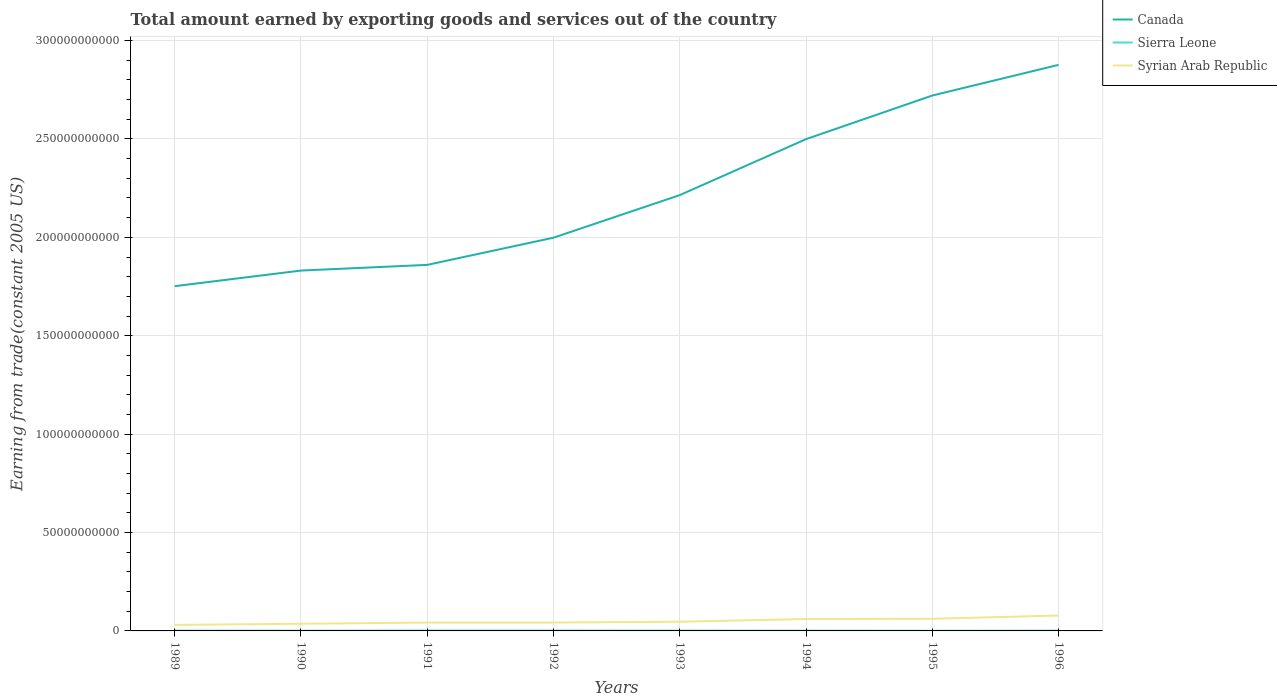How many different coloured lines are there?
Your answer should be very brief. 3. Is the number of lines equal to the number of legend labels?
Ensure brevity in your answer.  Yes. Across all years, what is the maximum total amount earned by exporting goods and services in Sierra Leone?
Offer a very short reply. 7.47e+07. What is the total total amount earned by exporting goods and services in Canada in the graph?
Your answer should be very brief. -2.16e+1. What is the difference between the highest and the second highest total amount earned by exporting goods and services in Canada?
Offer a very short reply. 1.12e+11. What is the difference between the highest and the lowest total amount earned by exporting goods and services in Syrian Arab Republic?
Offer a very short reply. 3. Is the total amount earned by exporting goods and services in Sierra Leone strictly greater than the total amount earned by exporting goods and services in Syrian Arab Republic over the years?
Make the answer very short. Yes. How many lines are there?
Ensure brevity in your answer.  3. Does the graph contain any zero values?
Make the answer very short. No. Does the graph contain grids?
Keep it short and to the point. Yes. Where does the legend appear in the graph?
Give a very brief answer. Top right. How many legend labels are there?
Offer a terse response. 3. How are the legend labels stacked?
Your answer should be compact. Vertical. What is the title of the graph?
Your response must be concise. Total amount earned by exporting goods and services out of the country. What is the label or title of the X-axis?
Your response must be concise. Years. What is the label or title of the Y-axis?
Provide a short and direct response. Earning from trade(constant 2005 US). What is the Earning from trade(constant 2005 US) in Canada in 1989?
Keep it short and to the point. 1.75e+11. What is the Earning from trade(constant 2005 US) of Sierra Leone in 1989?
Your answer should be very brief. 1.54e+08. What is the Earning from trade(constant 2005 US) of Syrian Arab Republic in 1989?
Provide a short and direct response. 3.07e+09. What is the Earning from trade(constant 2005 US) of Canada in 1990?
Make the answer very short. 1.83e+11. What is the Earning from trade(constant 2005 US) in Sierra Leone in 1990?
Your response must be concise. 1.25e+08. What is the Earning from trade(constant 2005 US) in Syrian Arab Republic in 1990?
Your response must be concise. 3.64e+09. What is the Earning from trade(constant 2005 US) of Canada in 1991?
Provide a succinct answer. 1.86e+11. What is the Earning from trade(constant 2005 US) in Sierra Leone in 1991?
Make the answer very short. 1.88e+08. What is the Earning from trade(constant 2005 US) of Syrian Arab Republic in 1991?
Your answer should be very brief. 4.25e+09. What is the Earning from trade(constant 2005 US) in Canada in 1992?
Your answer should be compact. 2.00e+11. What is the Earning from trade(constant 2005 US) in Sierra Leone in 1992?
Ensure brevity in your answer.  1.77e+08. What is the Earning from trade(constant 2005 US) of Syrian Arab Republic in 1992?
Make the answer very short. 4.25e+09. What is the Earning from trade(constant 2005 US) of Canada in 1993?
Keep it short and to the point. 2.21e+11. What is the Earning from trade(constant 2005 US) of Sierra Leone in 1993?
Keep it short and to the point. 1.53e+08. What is the Earning from trade(constant 2005 US) in Syrian Arab Republic in 1993?
Keep it short and to the point. 4.68e+09. What is the Earning from trade(constant 2005 US) in Canada in 1994?
Your answer should be very brief. 2.50e+11. What is the Earning from trade(constant 2005 US) in Sierra Leone in 1994?
Offer a very short reply. 1.17e+08. What is the Earning from trade(constant 2005 US) of Syrian Arab Republic in 1994?
Your answer should be very brief. 6.04e+09. What is the Earning from trade(constant 2005 US) of Canada in 1995?
Your response must be concise. 2.72e+11. What is the Earning from trade(constant 2005 US) in Sierra Leone in 1995?
Offer a very short reply. 7.47e+07. What is the Earning from trade(constant 2005 US) in Syrian Arab Republic in 1995?
Make the answer very short. 6.16e+09. What is the Earning from trade(constant 2005 US) of Canada in 1996?
Make the answer very short. 2.88e+11. What is the Earning from trade(constant 2005 US) in Sierra Leone in 1996?
Make the answer very short. 1.32e+08. What is the Earning from trade(constant 2005 US) of Syrian Arab Republic in 1996?
Make the answer very short. 7.84e+09. Across all years, what is the maximum Earning from trade(constant 2005 US) of Canada?
Ensure brevity in your answer.  2.88e+11. Across all years, what is the maximum Earning from trade(constant 2005 US) of Sierra Leone?
Your response must be concise. 1.88e+08. Across all years, what is the maximum Earning from trade(constant 2005 US) of Syrian Arab Republic?
Keep it short and to the point. 7.84e+09. Across all years, what is the minimum Earning from trade(constant 2005 US) of Canada?
Your response must be concise. 1.75e+11. Across all years, what is the minimum Earning from trade(constant 2005 US) of Sierra Leone?
Your response must be concise. 7.47e+07. Across all years, what is the minimum Earning from trade(constant 2005 US) of Syrian Arab Republic?
Keep it short and to the point. 3.07e+09. What is the total Earning from trade(constant 2005 US) of Canada in the graph?
Make the answer very short. 1.78e+12. What is the total Earning from trade(constant 2005 US) in Sierra Leone in the graph?
Provide a short and direct response. 1.12e+09. What is the total Earning from trade(constant 2005 US) of Syrian Arab Republic in the graph?
Your answer should be very brief. 3.99e+1. What is the difference between the Earning from trade(constant 2005 US) of Canada in 1989 and that in 1990?
Offer a very short reply. -7.93e+09. What is the difference between the Earning from trade(constant 2005 US) in Sierra Leone in 1989 and that in 1990?
Your answer should be compact. 2.88e+07. What is the difference between the Earning from trade(constant 2005 US) in Syrian Arab Republic in 1989 and that in 1990?
Your answer should be compact. -5.73e+08. What is the difference between the Earning from trade(constant 2005 US) of Canada in 1989 and that in 1991?
Your answer should be compact. -1.08e+1. What is the difference between the Earning from trade(constant 2005 US) of Sierra Leone in 1989 and that in 1991?
Your response must be concise. -3.45e+07. What is the difference between the Earning from trade(constant 2005 US) of Syrian Arab Republic in 1989 and that in 1991?
Provide a succinct answer. -1.18e+09. What is the difference between the Earning from trade(constant 2005 US) of Canada in 1989 and that in 1992?
Give a very brief answer. -2.46e+1. What is the difference between the Earning from trade(constant 2005 US) of Sierra Leone in 1989 and that in 1992?
Give a very brief answer. -2.33e+07. What is the difference between the Earning from trade(constant 2005 US) of Syrian Arab Republic in 1989 and that in 1992?
Make the answer very short. -1.19e+09. What is the difference between the Earning from trade(constant 2005 US) in Canada in 1989 and that in 1993?
Provide a short and direct response. -4.63e+1. What is the difference between the Earning from trade(constant 2005 US) of Sierra Leone in 1989 and that in 1993?
Provide a succinct answer. 3.92e+05. What is the difference between the Earning from trade(constant 2005 US) of Syrian Arab Republic in 1989 and that in 1993?
Make the answer very short. -1.61e+09. What is the difference between the Earning from trade(constant 2005 US) in Canada in 1989 and that in 1994?
Give a very brief answer. -7.47e+1. What is the difference between the Earning from trade(constant 2005 US) in Sierra Leone in 1989 and that in 1994?
Your answer should be very brief. 3.69e+07. What is the difference between the Earning from trade(constant 2005 US) of Syrian Arab Republic in 1989 and that in 1994?
Provide a succinct answer. -2.98e+09. What is the difference between the Earning from trade(constant 2005 US) in Canada in 1989 and that in 1995?
Keep it short and to the point. -9.69e+1. What is the difference between the Earning from trade(constant 2005 US) of Sierra Leone in 1989 and that in 1995?
Provide a succinct answer. 7.91e+07. What is the difference between the Earning from trade(constant 2005 US) of Syrian Arab Republic in 1989 and that in 1995?
Give a very brief answer. -3.09e+09. What is the difference between the Earning from trade(constant 2005 US) in Canada in 1989 and that in 1996?
Make the answer very short. -1.12e+11. What is the difference between the Earning from trade(constant 2005 US) of Sierra Leone in 1989 and that in 1996?
Offer a very short reply. 2.21e+07. What is the difference between the Earning from trade(constant 2005 US) in Syrian Arab Republic in 1989 and that in 1996?
Your answer should be very brief. -4.77e+09. What is the difference between the Earning from trade(constant 2005 US) in Canada in 1990 and that in 1991?
Ensure brevity in your answer.  -2.90e+09. What is the difference between the Earning from trade(constant 2005 US) of Sierra Leone in 1990 and that in 1991?
Make the answer very short. -6.33e+07. What is the difference between the Earning from trade(constant 2005 US) in Syrian Arab Republic in 1990 and that in 1991?
Provide a short and direct response. -6.11e+08. What is the difference between the Earning from trade(constant 2005 US) in Canada in 1990 and that in 1992?
Provide a short and direct response. -1.67e+1. What is the difference between the Earning from trade(constant 2005 US) of Sierra Leone in 1990 and that in 1992?
Provide a short and direct response. -5.21e+07. What is the difference between the Earning from trade(constant 2005 US) in Syrian Arab Republic in 1990 and that in 1992?
Provide a succinct answer. -6.13e+08. What is the difference between the Earning from trade(constant 2005 US) in Canada in 1990 and that in 1993?
Offer a terse response. -3.83e+1. What is the difference between the Earning from trade(constant 2005 US) in Sierra Leone in 1990 and that in 1993?
Your response must be concise. -2.84e+07. What is the difference between the Earning from trade(constant 2005 US) in Syrian Arab Republic in 1990 and that in 1993?
Ensure brevity in your answer.  -1.04e+09. What is the difference between the Earning from trade(constant 2005 US) of Canada in 1990 and that in 1994?
Offer a very short reply. -6.68e+1. What is the difference between the Earning from trade(constant 2005 US) of Sierra Leone in 1990 and that in 1994?
Your answer should be very brief. 8.15e+06. What is the difference between the Earning from trade(constant 2005 US) in Syrian Arab Republic in 1990 and that in 1994?
Give a very brief answer. -2.40e+09. What is the difference between the Earning from trade(constant 2005 US) of Canada in 1990 and that in 1995?
Make the answer very short. -8.89e+1. What is the difference between the Earning from trade(constant 2005 US) of Sierra Leone in 1990 and that in 1995?
Give a very brief answer. 5.03e+07. What is the difference between the Earning from trade(constant 2005 US) in Syrian Arab Republic in 1990 and that in 1995?
Give a very brief answer. -2.52e+09. What is the difference between the Earning from trade(constant 2005 US) of Canada in 1990 and that in 1996?
Provide a succinct answer. -1.05e+11. What is the difference between the Earning from trade(constant 2005 US) of Sierra Leone in 1990 and that in 1996?
Provide a short and direct response. -6.70e+06. What is the difference between the Earning from trade(constant 2005 US) in Syrian Arab Republic in 1990 and that in 1996?
Offer a terse response. -4.20e+09. What is the difference between the Earning from trade(constant 2005 US) in Canada in 1991 and that in 1992?
Your answer should be very brief. -1.38e+1. What is the difference between the Earning from trade(constant 2005 US) of Sierra Leone in 1991 and that in 1992?
Keep it short and to the point. 1.12e+07. What is the difference between the Earning from trade(constant 2005 US) in Syrian Arab Republic in 1991 and that in 1992?
Offer a very short reply. -2.40e+06. What is the difference between the Earning from trade(constant 2005 US) in Canada in 1991 and that in 1993?
Provide a succinct answer. -3.54e+1. What is the difference between the Earning from trade(constant 2005 US) of Sierra Leone in 1991 and that in 1993?
Offer a terse response. 3.49e+07. What is the difference between the Earning from trade(constant 2005 US) in Syrian Arab Republic in 1991 and that in 1993?
Your answer should be compact. -4.28e+08. What is the difference between the Earning from trade(constant 2005 US) of Canada in 1991 and that in 1994?
Offer a terse response. -6.39e+1. What is the difference between the Earning from trade(constant 2005 US) of Sierra Leone in 1991 and that in 1994?
Provide a short and direct response. 7.15e+07. What is the difference between the Earning from trade(constant 2005 US) in Syrian Arab Republic in 1991 and that in 1994?
Provide a short and direct response. -1.79e+09. What is the difference between the Earning from trade(constant 2005 US) in Canada in 1991 and that in 1995?
Keep it short and to the point. -8.60e+1. What is the difference between the Earning from trade(constant 2005 US) in Sierra Leone in 1991 and that in 1995?
Keep it short and to the point. 1.14e+08. What is the difference between the Earning from trade(constant 2005 US) in Syrian Arab Republic in 1991 and that in 1995?
Offer a terse response. -1.91e+09. What is the difference between the Earning from trade(constant 2005 US) of Canada in 1991 and that in 1996?
Your response must be concise. -1.02e+11. What is the difference between the Earning from trade(constant 2005 US) in Sierra Leone in 1991 and that in 1996?
Make the answer very short. 5.66e+07. What is the difference between the Earning from trade(constant 2005 US) of Syrian Arab Republic in 1991 and that in 1996?
Provide a succinct answer. -3.59e+09. What is the difference between the Earning from trade(constant 2005 US) in Canada in 1992 and that in 1993?
Offer a very short reply. -2.16e+1. What is the difference between the Earning from trade(constant 2005 US) of Sierra Leone in 1992 and that in 1993?
Your answer should be very brief. 2.37e+07. What is the difference between the Earning from trade(constant 2005 US) in Syrian Arab Republic in 1992 and that in 1993?
Offer a terse response. -4.26e+08. What is the difference between the Earning from trade(constant 2005 US) in Canada in 1992 and that in 1994?
Offer a terse response. -5.01e+1. What is the difference between the Earning from trade(constant 2005 US) of Sierra Leone in 1992 and that in 1994?
Give a very brief answer. 6.02e+07. What is the difference between the Earning from trade(constant 2005 US) of Syrian Arab Republic in 1992 and that in 1994?
Give a very brief answer. -1.79e+09. What is the difference between the Earning from trade(constant 2005 US) in Canada in 1992 and that in 1995?
Provide a succinct answer. -7.22e+1. What is the difference between the Earning from trade(constant 2005 US) of Sierra Leone in 1992 and that in 1995?
Offer a terse response. 1.02e+08. What is the difference between the Earning from trade(constant 2005 US) of Syrian Arab Republic in 1992 and that in 1995?
Your answer should be very brief. -1.91e+09. What is the difference between the Earning from trade(constant 2005 US) of Canada in 1992 and that in 1996?
Your response must be concise. -8.78e+1. What is the difference between the Earning from trade(constant 2005 US) in Sierra Leone in 1992 and that in 1996?
Ensure brevity in your answer.  4.54e+07. What is the difference between the Earning from trade(constant 2005 US) of Syrian Arab Republic in 1992 and that in 1996?
Make the answer very short. -3.59e+09. What is the difference between the Earning from trade(constant 2005 US) of Canada in 1993 and that in 1994?
Make the answer very short. -2.84e+1. What is the difference between the Earning from trade(constant 2005 US) of Sierra Leone in 1993 and that in 1994?
Your response must be concise. 3.65e+07. What is the difference between the Earning from trade(constant 2005 US) of Syrian Arab Republic in 1993 and that in 1994?
Provide a short and direct response. -1.36e+09. What is the difference between the Earning from trade(constant 2005 US) in Canada in 1993 and that in 1995?
Your answer should be very brief. -5.06e+1. What is the difference between the Earning from trade(constant 2005 US) of Sierra Leone in 1993 and that in 1995?
Give a very brief answer. 7.87e+07. What is the difference between the Earning from trade(constant 2005 US) of Syrian Arab Republic in 1993 and that in 1995?
Keep it short and to the point. -1.48e+09. What is the difference between the Earning from trade(constant 2005 US) in Canada in 1993 and that in 1996?
Ensure brevity in your answer.  -6.62e+1. What is the difference between the Earning from trade(constant 2005 US) in Sierra Leone in 1993 and that in 1996?
Give a very brief answer. 2.17e+07. What is the difference between the Earning from trade(constant 2005 US) of Syrian Arab Republic in 1993 and that in 1996?
Your answer should be compact. -3.16e+09. What is the difference between the Earning from trade(constant 2005 US) of Canada in 1994 and that in 1995?
Ensure brevity in your answer.  -2.22e+1. What is the difference between the Earning from trade(constant 2005 US) of Sierra Leone in 1994 and that in 1995?
Give a very brief answer. 4.22e+07. What is the difference between the Earning from trade(constant 2005 US) in Syrian Arab Republic in 1994 and that in 1995?
Offer a terse response. -1.17e+08. What is the difference between the Earning from trade(constant 2005 US) of Canada in 1994 and that in 1996?
Your response must be concise. -3.77e+1. What is the difference between the Earning from trade(constant 2005 US) of Sierra Leone in 1994 and that in 1996?
Give a very brief answer. -1.48e+07. What is the difference between the Earning from trade(constant 2005 US) in Syrian Arab Republic in 1994 and that in 1996?
Give a very brief answer. -1.80e+09. What is the difference between the Earning from trade(constant 2005 US) of Canada in 1995 and that in 1996?
Provide a short and direct response. -1.56e+1. What is the difference between the Earning from trade(constant 2005 US) in Sierra Leone in 1995 and that in 1996?
Offer a terse response. -5.70e+07. What is the difference between the Earning from trade(constant 2005 US) in Syrian Arab Republic in 1995 and that in 1996?
Offer a very short reply. -1.68e+09. What is the difference between the Earning from trade(constant 2005 US) in Canada in 1989 and the Earning from trade(constant 2005 US) in Sierra Leone in 1990?
Make the answer very short. 1.75e+11. What is the difference between the Earning from trade(constant 2005 US) in Canada in 1989 and the Earning from trade(constant 2005 US) in Syrian Arab Republic in 1990?
Your answer should be very brief. 1.72e+11. What is the difference between the Earning from trade(constant 2005 US) of Sierra Leone in 1989 and the Earning from trade(constant 2005 US) of Syrian Arab Republic in 1990?
Your answer should be compact. -3.48e+09. What is the difference between the Earning from trade(constant 2005 US) in Canada in 1989 and the Earning from trade(constant 2005 US) in Sierra Leone in 1991?
Provide a short and direct response. 1.75e+11. What is the difference between the Earning from trade(constant 2005 US) in Canada in 1989 and the Earning from trade(constant 2005 US) in Syrian Arab Republic in 1991?
Offer a very short reply. 1.71e+11. What is the difference between the Earning from trade(constant 2005 US) of Sierra Leone in 1989 and the Earning from trade(constant 2005 US) of Syrian Arab Republic in 1991?
Give a very brief answer. -4.10e+09. What is the difference between the Earning from trade(constant 2005 US) of Canada in 1989 and the Earning from trade(constant 2005 US) of Sierra Leone in 1992?
Offer a very short reply. 1.75e+11. What is the difference between the Earning from trade(constant 2005 US) in Canada in 1989 and the Earning from trade(constant 2005 US) in Syrian Arab Republic in 1992?
Make the answer very short. 1.71e+11. What is the difference between the Earning from trade(constant 2005 US) in Sierra Leone in 1989 and the Earning from trade(constant 2005 US) in Syrian Arab Republic in 1992?
Keep it short and to the point. -4.10e+09. What is the difference between the Earning from trade(constant 2005 US) of Canada in 1989 and the Earning from trade(constant 2005 US) of Sierra Leone in 1993?
Keep it short and to the point. 1.75e+11. What is the difference between the Earning from trade(constant 2005 US) of Canada in 1989 and the Earning from trade(constant 2005 US) of Syrian Arab Republic in 1993?
Keep it short and to the point. 1.71e+11. What is the difference between the Earning from trade(constant 2005 US) in Sierra Leone in 1989 and the Earning from trade(constant 2005 US) in Syrian Arab Republic in 1993?
Your response must be concise. -4.52e+09. What is the difference between the Earning from trade(constant 2005 US) of Canada in 1989 and the Earning from trade(constant 2005 US) of Sierra Leone in 1994?
Provide a succinct answer. 1.75e+11. What is the difference between the Earning from trade(constant 2005 US) in Canada in 1989 and the Earning from trade(constant 2005 US) in Syrian Arab Republic in 1994?
Your answer should be very brief. 1.69e+11. What is the difference between the Earning from trade(constant 2005 US) in Sierra Leone in 1989 and the Earning from trade(constant 2005 US) in Syrian Arab Republic in 1994?
Your response must be concise. -5.89e+09. What is the difference between the Earning from trade(constant 2005 US) of Canada in 1989 and the Earning from trade(constant 2005 US) of Sierra Leone in 1995?
Provide a succinct answer. 1.75e+11. What is the difference between the Earning from trade(constant 2005 US) of Canada in 1989 and the Earning from trade(constant 2005 US) of Syrian Arab Republic in 1995?
Provide a short and direct response. 1.69e+11. What is the difference between the Earning from trade(constant 2005 US) of Sierra Leone in 1989 and the Earning from trade(constant 2005 US) of Syrian Arab Republic in 1995?
Provide a succinct answer. -6.00e+09. What is the difference between the Earning from trade(constant 2005 US) of Canada in 1989 and the Earning from trade(constant 2005 US) of Sierra Leone in 1996?
Your answer should be very brief. 1.75e+11. What is the difference between the Earning from trade(constant 2005 US) in Canada in 1989 and the Earning from trade(constant 2005 US) in Syrian Arab Republic in 1996?
Provide a succinct answer. 1.67e+11. What is the difference between the Earning from trade(constant 2005 US) in Sierra Leone in 1989 and the Earning from trade(constant 2005 US) in Syrian Arab Republic in 1996?
Give a very brief answer. -7.69e+09. What is the difference between the Earning from trade(constant 2005 US) in Canada in 1990 and the Earning from trade(constant 2005 US) in Sierra Leone in 1991?
Your answer should be compact. 1.83e+11. What is the difference between the Earning from trade(constant 2005 US) in Canada in 1990 and the Earning from trade(constant 2005 US) in Syrian Arab Republic in 1991?
Your answer should be compact. 1.79e+11. What is the difference between the Earning from trade(constant 2005 US) in Sierra Leone in 1990 and the Earning from trade(constant 2005 US) in Syrian Arab Republic in 1991?
Keep it short and to the point. -4.12e+09. What is the difference between the Earning from trade(constant 2005 US) of Canada in 1990 and the Earning from trade(constant 2005 US) of Sierra Leone in 1992?
Your response must be concise. 1.83e+11. What is the difference between the Earning from trade(constant 2005 US) in Canada in 1990 and the Earning from trade(constant 2005 US) in Syrian Arab Republic in 1992?
Provide a short and direct response. 1.79e+11. What is the difference between the Earning from trade(constant 2005 US) of Sierra Leone in 1990 and the Earning from trade(constant 2005 US) of Syrian Arab Republic in 1992?
Keep it short and to the point. -4.13e+09. What is the difference between the Earning from trade(constant 2005 US) in Canada in 1990 and the Earning from trade(constant 2005 US) in Sierra Leone in 1993?
Offer a very short reply. 1.83e+11. What is the difference between the Earning from trade(constant 2005 US) of Canada in 1990 and the Earning from trade(constant 2005 US) of Syrian Arab Republic in 1993?
Offer a terse response. 1.78e+11. What is the difference between the Earning from trade(constant 2005 US) in Sierra Leone in 1990 and the Earning from trade(constant 2005 US) in Syrian Arab Republic in 1993?
Your answer should be compact. -4.55e+09. What is the difference between the Earning from trade(constant 2005 US) in Canada in 1990 and the Earning from trade(constant 2005 US) in Sierra Leone in 1994?
Give a very brief answer. 1.83e+11. What is the difference between the Earning from trade(constant 2005 US) of Canada in 1990 and the Earning from trade(constant 2005 US) of Syrian Arab Republic in 1994?
Your answer should be compact. 1.77e+11. What is the difference between the Earning from trade(constant 2005 US) of Sierra Leone in 1990 and the Earning from trade(constant 2005 US) of Syrian Arab Republic in 1994?
Offer a very short reply. -5.92e+09. What is the difference between the Earning from trade(constant 2005 US) in Canada in 1990 and the Earning from trade(constant 2005 US) in Sierra Leone in 1995?
Your answer should be very brief. 1.83e+11. What is the difference between the Earning from trade(constant 2005 US) in Canada in 1990 and the Earning from trade(constant 2005 US) in Syrian Arab Republic in 1995?
Keep it short and to the point. 1.77e+11. What is the difference between the Earning from trade(constant 2005 US) in Sierra Leone in 1990 and the Earning from trade(constant 2005 US) in Syrian Arab Republic in 1995?
Offer a very short reply. -6.03e+09. What is the difference between the Earning from trade(constant 2005 US) of Canada in 1990 and the Earning from trade(constant 2005 US) of Sierra Leone in 1996?
Give a very brief answer. 1.83e+11. What is the difference between the Earning from trade(constant 2005 US) of Canada in 1990 and the Earning from trade(constant 2005 US) of Syrian Arab Republic in 1996?
Keep it short and to the point. 1.75e+11. What is the difference between the Earning from trade(constant 2005 US) in Sierra Leone in 1990 and the Earning from trade(constant 2005 US) in Syrian Arab Republic in 1996?
Make the answer very short. -7.71e+09. What is the difference between the Earning from trade(constant 2005 US) of Canada in 1991 and the Earning from trade(constant 2005 US) of Sierra Leone in 1992?
Keep it short and to the point. 1.86e+11. What is the difference between the Earning from trade(constant 2005 US) of Canada in 1991 and the Earning from trade(constant 2005 US) of Syrian Arab Republic in 1992?
Your response must be concise. 1.82e+11. What is the difference between the Earning from trade(constant 2005 US) of Sierra Leone in 1991 and the Earning from trade(constant 2005 US) of Syrian Arab Republic in 1992?
Your answer should be compact. -4.06e+09. What is the difference between the Earning from trade(constant 2005 US) of Canada in 1991 and the Earning from trade(constant 2005 US) of Sierra Leone in 1993?
Provide a succinct answer. 1.86e+11. What is the difference between the Earning from trade(constant 2005 US) in Canada in 1991 and the Earning from trade(constant 2005 US) in Syrian Arab Republic in 1993?
Make the answer very short. 1.81e+11. What is the difference between the Earning from trade(constant 2005 US) in Sierra Leone in 1991 and the Earning from trade(constant 2005 US) in Syrian Arab Republic in 1993?
Ensure brevity in your answer.  -4.49e+09. What is the difference between the Earning from trade(constant 2005 US) of Canada in 1991 and the Earning from trade(constant 2005 US) of Sierra Leone in 1994?
Your response must be concise. 1.86e+11. What is the difference between the Earning from trade(constant 2005 US) in Canada in 1991 and the Earning from trade(constant 2005 US) in Syrian Arab Republic in 1994?
Offer a terse response. 1.80e+11. What is the difference between the Earning from trade(constant 2005 US) in Sierra Leone in 1991 and the Earning from trade(constant 2005 US) in Syrian Arab Republic in 1994?
Offer a very short reply. -5.85e+09. What is the difference between the Earning from trade(constant 2005 US) of Canada in 1991 and the Earning from trade(constant 2005 US) of Sierra Leone in 1995?
Offer a terse response. 1.86e+11. What is the difference between the Earning from trade(constant 2005 US) in Canada in 1991 and the Earning from trade(constant 2005 US) in Syrian Arab Republic in 1995?
Ensure brevity in your answer.  1.80e+11. What is the difference between the Earning from trade(constant 2005 US) of Sierra Leone in 1991 and the Earning from trade(constant 2005 US) of Syrian Arab Republic in 1995?
Ensure brevity in your answer.  -5.97e+09. What is the difference between the Earning from trade(constant 2005 US) in Canada in 1991 and the Earning from trade(constant 2005 US) in Sierra Leone in 1996?
Your answer should be compact. 1.86e+11. What is the difference between the Earning from trade(constant 2005 US) of Canada in 1991 and the Earning from trade(constant 2005 US) of Syrian Arab Republic in 1996?
Provide a short and direct response. 1.78e+11. What is the difference between the Earning from trade(constant 2005 US) of Sierra Leone in 1991 and the Earning from trade(constant 2005 US) of Syrian Arab Republic in 1996?
Your answer should be very brief. -7.65e+09. What is the difference between the Earning from trade(constant 2005 US) of Canada in 1992 and the Earning from trade(constant 2005 US) of Sierra Leone in 1993?
Give a very brief answer. 2.00e+11. What is the difference between the Earning from trade(constant 2005 US) in Canada in 1992 and the Earning from trade(constant 2005 US) in Syrian Arab Republic in 1993?
Your answer should be compact. 1.95e+11. What is the difference between the Earning from trade(constant 2005 US) of Sierra Leone in 1992 and the Earning from trade(constant 2005 US) of Syrian Arab Republic in 1993?
Provide a short and direct response. -4.50e+09. What is the difference between the Earning from trade(constant 2005 US) of Canada in 1992 and the Earning from trade(constant 2005 US) of Sierra Leone in 1994?
Offer a very short reply. 2.00e+11. What is the difference between the Earning from trade(constant 2005 US) of Canada in 1992 and the Earning from trade(constant 2005 US) of Syrian Arab Republic in 1994?
Your answer should be compact. 1.94e+11. What is the difference between the Earning from trade(constant 2005 US) of Sierra Leone in 1992 and the Earning from trade(constant 2005 US) of Syrian Arab Republic in 1994?
Offer a very short reply. -5.86e+09. What is the difference between the Earning from trade(constant 2005 US) of Canada in 1992 and the Earning from trade(constant 2005 US) of Sierra Leone in 1995?
Your answer should be very brief. 2.00e+11. What is the difference between the Earning from trade(constant 2005 US) of Canada in 1992 and the Earning from trade(constant 2005 US) of Syrian Arab Republic in 1995?
Provide a short and direct response. 1.94e+11. What is the difference between the Earning from trade(constant 2005 US) of Sierra Leone in 1992 and the Earning from trade(constant 2005 US) of Syrian Arab Republic in 1995?
Provide a short and direct response. -5.98e+09. What is the difference between the Earning from trade(constant 2005 US) of Canada in 1992 and the Earning from trade(constant 2005 US) of Sierra Leone in 1996?
Give a very brief answer. 2.00e+11. What is the difference between the Earning from trade(constant 2005 US) in Canada in 1992 and the Earning from trade(constant 2005 US) in Syrian Arab Republic in 1996?
Your answer should be compact. 1.92e+11. What is the difference between the Earning from trade(constant 2005 US) of Sierra Leone in 1992 and the Earning from trade(constant 2005 US) of Syrian Arab Republic in 1996?
Give a very brief answer. -7.66e+09. What is the difference between the Earning from trade(constant 2005 US) in Canada in 1993 and the Earning from trade(constant 2005 US) in Sierra Leone in 1994?
Ensure brevity in your answer.  2.21e+11. What is the difference between the Earning from trade(constant 2005 US) of Canada in 1993 and the Earning from trade(constant 2005 US) of Syrian Arab Republic in 1994?
Your response must be concise. 2.15e+11. What is the difference between the Earning from trade(constant 2005 US) in Sierra Leone in 1993 and the Earning from trade(constant 2005 US) in Syrian Arab Republic in 1994?
Offer a terse response. -5.89e+09. What is the difference between the Earning from trade(constant 2005 US) of Canada in 1993 and the Earning from trade(constant 2005 US) of Sierra Leone in 1995?
Offer a terse response. 2.21e+11. What is the difference between the Earning from trade(constant 2005 US) in Canada in 1993 and the Earning from trade(constant 2005 US) in Syrian Arab Republic in 1995?
Keep it short and to the point. 2.15e+11. What is the difference between the Earning from trade(constant 2005 US) in Sierra Leone in 1993 and the Earning from trade(constant 2005 US) in Syrian Arab Republic in 1995?
Your answer should be very brief. -6.00e+09. What is the difference between the Earning from trade(constant 2005 US) in Canada in 1993 and the Earning from trade(constant 2005 US) in Sierra Leone in 1996?
Give a very brief answer. 2.21e+11. What is the difference between the Earning from trade(constant 2005 US) of Canada in 1993 and the Earning from trade(constant 2005 US) of Syrian Arab Republic in 1996?
Offer a terse response. 2.14e+11. What is the difference between the Earning from trade(constant 2005 US) in Sierra Leone in 1993 and the Earning from trade(constant 2005 US) in Syrian Arab Republic in 1996?
Offer a very short reply. -7.69e+09. What is the difference between the Earning from trade(constant 2005 US) of Canada in 1994 and the Earning from trade(constant 2005 US) of Sierra Leone in 1995?
Offer a terse response. 2.50e+11. What is the difference between the Earning from trade(constant 2005 US) of Canada in 1994 and the Earning from trade(constant 2005 US) of Syrian Arab Republic in 1995?
Offer a very short reply. 2.44e+11. What is the difference between the Earning from trade(constant 2005 US) of Sierra Leone in 1994 and the Earning from trade(constant 2005 US) of Syrian Arab Republic in 1995?
Ensure brevity in your answer.  -6.04e+09. What is the difference between the Earning from trade(constant 2005 US) of Canada in 1994 and the Earning from trade(constant 2005 US) of Sierra Leone in 1996?
Keep it short and to the point. 2.50e+11. What is the difference between the Earning from trade(constant 2005 US) of Canada in 1994 and the Earning from trade(constant 2005 US) of Syrian Arab Republic in 1996?
Offer a terse response. 2.42e+11. What is the difference between the Earning from trade(constant 2005 US) in Sierra Leone in 1994 and the Earning from trade(constant 2005 US) in Syrian Arab Republic in 1996?
Ensure brevity in your answer.  -7.72e+09. What is the difference between the Earning from trade(constant 2005 US) in Canada in 1995 and the Earning from trade(constant 2005 US) in Sierra Leone in 1996?
Make the answer very short. 2.72e+11. What is the difference between the Earning from trade(constant 2005 US) of Canada in 1995 and the Earning from trade(constant 2005 US) of Syrian Arab Republic in 1996?
Offer a terse response. 2.64e+11. What is the difference between the Earning from trade(constant 2005 US) in Sierra Leone in 1995 and the Earning from trade(constant 2005 US) in Syrian Arab Republic in 1996?
Keep it short and to the point. -7.76e+09. What is the average Earning from trade(constant 2005 US) in Canada per year?
Ensure brevity in your answer.  2.22e+11. What is the average Earning from trade(constant 2005 US) of Sierra Leone per year?
Provide a succinct answer. 1.40e+08. What is the average Earning from trade(constant 2005 US) of Syrian Arab Republic per year?
Your response must be concise. 4.99e+09. In the year 1989, what is the difference between the Earning from trade(constant 2005 US) of Canada and Earning from trade(constant 2005 US) of Sierra Leone?
Provide a succinct answer. 1.75e+11. In the year 1989, what is the difference between the Earning from trade(constant 2005 US) of Canada and Earning from trade(constant 2005 US) of Syrian Arab Republic?
Give a very brief answer. 1.72e+11. In the year 1989, what is the difference between the Earning from trade(constant 2005 US) in Sierra Leone and Earning from trade(constant 2005 US) in Syrian Arab Republic?
Offer a terse response. -2.91e+09. In the year 1990, what is the difference between the Earning from trade(constant 2005 US) in Canada and Earning from trade(constant 2005 US) in Sierra Leone?
Make the answer very short. 1.83e+11. In the year 1990, what is the difference between the Earning from trade(constant 2005 US) of Canada and Earning from trade(constant 2005 US) of Syrian Arab Republic?
Provide a succinct answer. 1.79e+11. In the year 1990, what is the difference between the Earning from trade(constant 2005 US) of Sierra Leone and Earning from trade(constant 2005 US) of Syrian Arab Republic?
Give a very brief answer. -3.51e+09. In the year 1991, what is the difference between the Earning from trade(constant 2005 US) in Canada and Earning from trade(constant 2005 US) in Sierra Leone?
Give a very brief answer. 1.86e+11. In the year 1991, what is the difference between the Earning from trade(constant 2005 US) of Canada and Earning from trade(constant 2005 US) of Syrian Arab Republic?
Ensure brevity in your answer.  1.82e+11. In the year 1991, what is the difference between the Earning from trade(constant 2005 US) of Sierra Leone and Earning from trade(constant 2005 US) of Syrian Arab Republic?
Provide a succinct answer. -4.06e+09. In the year 1992, what is the difference between the Earning from trade(constant 2005 US) of Canada and Earning from trade(constant 2005 US) of Sierra Leone?
Your answer should be very brief. 2.00e+11. In the year 1992, what is the difference between the Earning from trade(constant 2005 US) in Canada and Earning from trade(constant 2005 US) in Syrian Arab Republic?
Your answer should be compact. 1.96e+11. In the year 1992, what is the difference between the Earning from trade(constant 2005 US) of Sierra Leone and Earning from trade(constant 2005 US) of Syrian Arab Republic?
Provide a short and direct response. -4.07e+09. In the year 1993, what is the difference between the Earning from trade(constant 2005 US) of Canada and Earning from trade(constant 2005 US) of Sierra Leone?
Offer a terse response. 2.21e+11. In the year 1993, what is the difference between the Earning from trade(constant 2005 US) of Canada and Earning from trade(constant 2005 US) of Syrian Arab Republic?
Your answer should be compact. 2.17e+11. In the year 1993, what is the difference between the Earning from trade(constant 2005 US) in Sierra Leone and Earning from trade(constant 2005 US) in Syrian Arab Republic?
Provide a short and direct response. -4.52e+09. In the year 1994, what is the difference between the Earning from trade(constant 2005 US) of Canada and Earning from trade(constant 2005 US) of Sierra Leone?
Your answer should be compact. 2.50e+11. In the year 1994, what is the difference between the Earning from trade(constant 2005 US) in Canada and Earning from trade(constant 2005 US) in Syrian Arab Republic?
Your answer should be very brief. 2.44e+11. In the year 1994, what is the difference between the Earning from trade(constant 2005 US) in Sierra Leone and Earning from trade(constant 2005 US) in Syrian Arab Republic?
Offer a very short reply. -5.92e+09. In the year 1995, what is the difference between the Earning from trade(constant 2005 US) of Canada and Earning from trade(constant 2005 US) of Sierra Leone?
Keep it short and to the point. 2.72e+11. In the year 1995, what is the difference between the Earning from trade(constant 2005 US) in Canada and Earning from trade(constant 2005 US) in Syrian Arab Republic?
Make the answer very short. 2.66e+11. In the year 1995, what is the difference between the Earning from trade(constant 2005 US) in Sierra Leone and Earning from trade(constant 2005 US) in Syrian Arab Republic?
Your answer should be compact. -6.08e+09. In the year 1996, what is the difference between the Earning from trade(constant 2005 US) of Canada and Earning from trade(constant 2005 US) of Sierra Leone?
Provide a short and direct response. 2.87e+11. In the year 1996, what is the difference between the Earning from trade(constant 2005 US) of Canada and Earning from trade(constant 2005 US) of Syrian Arab Republic?
Your answer should be compact. 2.80e+11. In the year 1996, what is the difference between the Earning from trade(constant 2005 US) in Sierra Leone and Earning from trade(constant 2005 US) in Syrian Arab Republic?
Provide a short and direct response. -7.71e+09. What is the ratio of the Earning from trade(constant 2005 US) in Canada in 1989 to that in 1990?
Make the answer very short. 0.96. What is the ratio of the Earning from trade(constant 2005 US) in Sierra Leone in 1989 to that in 1990?
Provide a short and direct response. 1.23. What is the ratio of the Earning from trade(constant 2005 US) of Syrian Arab Republic in 1989 to that in 1990?
Provide a short and direct response. 0.84. What is the ratio of the Earning from trade(constant 2005 US) in Canada in 1989 to that in 1991?
Offer a very short reply. 0.94. What is the ratio of the Earning from trade(constant 2005 US) in Sierra Leone in 1989 to that in 1991?
Provide a succinct answer. 0.82. What is the ratio of the Earning from trade(constant 2005 US) of Syrian Arab Republic in 1989 to that in 1991?
Give a very brief answer. 0.72. What is the ratio of the Earning from trade(constant 2005 US) in Canada in 1989 to that in 1992?
Keep it short and to the point. 0.88. What is the ratio of the Earning from trade(constant 2005 US) of Sierra Leone in 1989 to that in 1992?
Ensure brevity in your answer.  0.87. What is the ratio of the Earning from trade(constant 2005 US) in Syrian Arab Republic in 1989 to that in 1992?
Give a very brief answer. 0.72. What is the ratio of the Earning from trade(constant 2005 US) in Canada in 1989 to that in 1993?
Offer a terse response. 0.79. What is the ratio of the Earning from trade(constant 2005 US) of Syrian Arab Republic in 1989 to that in 1993?
Your answer should be compact. 0.66. What is the ratio of the Earning from trade(constant 2005 US) of Canada in 1989 to that in 1994?
Offer a terse response. 0.7. What is the ratio of the Earning from trade(constant 2005 US) of Sierra Leone in 1989 to that in 1994?
Offer a terse response. 1.32. What is the ratio of the Earning from trade(constant 2005 US) of Syrian Arab Republic in 1989 to that in 1994?
Offer a very short reply. 0.51. What is the ratio of the Earning from trade(constant 2005 US) in Canada in 1989 to that in 1995?
Provide a short and direct response. 0.64. What is the ratio of the Earning from trade(constant 2005 US) of Sierra Leone in 1989 to that in 1995?
Your response must be concise. 2.06. What is the ratio of the Earning from trade(constant 2005 US) in Syrian Arab Republic in 1989 to that in 1995?
Provide a short and direct response. 0.5. What is the ratio of the Earning from trade(constant 2005 US) in Canada in 1989 to that in 1996?
Provide a short and direct response. 0.61. What is the ratio of the Earning from trade(constant 2005 US) in Sierra Leone in 1989 to that in 1996?
Provide a succinct answer. 1.17. What is the ratio of the Earning from trade(constant 2005 US) of Syrian Arab Republic in 1989 to that in 1996?
Keep it short and to the point. 0.39. What is the ratio of the Earning from trade(constant 2005 US) in Canada in 1990 to that in 1991?
Your answer should be compact. 0.98. What is the ratio of the Earning from trade(constant 2005 US) in Sierra Leone in 1990 to that in 1991?
Ensure brevity in your answer.  0.66. What is the ratio of the Earning from trade(constant 2005 US) in Syrian Arab Republic in 1990 to that in 1991?
Offer a terse response. 0.86. What is the ratio of the Earning from trade(constant 2005 US) in Canada in 1990 to that in 1992?
Provide a short and direct response. 0.92. What is the ratio of the Earning from trade(constant 2005 US) of Sierra Leone in 1990 to that in 1992?
Provide a succinct answer. 0.71. What is the ratio of the Earning from trade(constant 2005 US) in Syrian Arab Republic in 1990 to that in 1992?
Offer a terse response. 0.86. What is the ratio of the Earning from trade(constant 2005 US) in Canada in 1990 to that in 1993?
Your answer should be compact. 0.83. What is the ratio of the Earning from trade(constant 2005 US) in Sierra Leone in 1990 to that in 1993?
Keep it short and to the point. 0.81. What is the ratio of the Earning from trade(constant 2005 US) in Syrian Arab Republic in 1990 to that in 1993?
Give a very brief answer. 0.78. What is the ratio of the Earning from trade(constant 2005 US) of Canada in 1990 to that in 1994?
Offer a terse response. 0.73. What is the ratio of the Earning from trade(constant 2005 US) of Sierra Leone in 1990 to that in 1994?
Keep it short and to the point. 1.07. What is the ratio of the Earning from trade(constant 2005 US) of Syrian Arab Republic in 1990 to that in 1994?
Keep it short and to the point. 0.6. What is the ratio of the Earning from trade(constant 2005 US) of Canada in 1990 to that in 1995?
Provide a succinct answer. 0.67. What is the ratio of the Earning from trade(constant 2005 US) in Sierra Leone in 1990 to that in 1995?
Provide a succinct answer. 1.67. What is the ratio of the Earning from trade(constant 2005 US) of Syrian Arab Republic in 1990 to that in 1995?
Your response must be concise. 0.59. What is the ratio of the Earning from trade(constant 2005 US) in Canada in 1990 to that in 1996?
Provide a short and direct response. 0.64. What is the ratio of the Earning from trade(constant 2005 US) of Sierra Leone in 1990 to that in 1996?
Keep it short and to the point. 0.95. What is the ratio of the Earning from trade(constant 2005 US) of Syrian Arab Republic in 1990 to that in 1996?
Give a very brief answer. 0.46. What is the ratio of the Earning from trade(constant 2005 US) of Canada in 1991 to that in 1992?
Your response must be concise. 0.93. What is the ratio of the Earning from trade(constant 2005 US) in Sierra Leone in 1991 to that in 1992?
Provide a succinct answer. 1.06. What is the ratio of the Earning from trade(constant 2005 US) in Canada in 1991 to that in 1993?
Offer a very short reply. 0.84. What is the ratio of the Earning from trade(constant 2005 US) of Sierra Leone in 1991 to that in 1993?
Your answer should be very brief. 1.23. What is the ratio of the Earning from trade(constant 2005 US) of Syrian Arab Republic in 1991 to that in 1993?
Keep it short and to the point. 0.91. What is the ratio of the Earning from trade(constant 2005 US) in Canada in 1991 to that in 1994?
Your answer should be very brief. 0.74. What is the ratio of the Earning from trade(constant 2005 US) of Sierra Leone in 1991 to that in 1994?
Make the answer very short. 1.61. What is the ratio of the Earning from trade(constant 2005 US) of Syrian Arab Republic in 1991 to that in 1994?
Your answer should be compact. 0.7. What is the ratio of the Earning from trade(constant 2005 US) in Canada in 1991 to that in 1995?
Give a very brief answer. 0.68. What is the ratio of the Earning from trade(constant 2005 US) in Sierra Leone in 1991 to that in 1995?
Provide a succinct answer. 2.52. What is the ratio of the Earning from trade(constant 2005 US) of Syrian Arab Republic in 1991 to that in 1995?
Your answer should be compact. 0.69. What is the ratio of the Earning from trade(constant 2005 US) in Canada in 1991 to that in 1996?
Your answer should be compact. 0.65. What is the ratio of the Earning from trade(constant 2005 US) in Sierra Leone in 1991 to that in 1996?
Your answer should be very brief. 1.43. What is the ratio of the Earning from trade(constant 2005 US) of Syrian Arab Republic in 1991 to that in 1996?
Your response must be concise. 0.54. What is the ratio of the Earning from trade(constant 2005 US) in Canada in 1992 to that in 1993?
Your answer should be compact. 0.9. What is the ratio of the Earning from trade(constant 2005 US) of Sierra Leone in 1992 to that in 1993?
Keep it short and to the point. 1.15. What is the ratio of the Earning from trade(constant 2005 US) of Syrian Arab Republic in 1992 to that in 1993?
Offer a very short reply. 0.91. What is the ratio of the Earning from trade(constant 2005 US) of Canada in 1992 to that in 1994?
Provide a short and direct response. 0.8. What is the ratio of the Earning from trade(constant 2005 US) in Sierra Leone in 1992 to that in 1994?
Offer a very short reply. 1.52. What is the ratio of the Earning from trade(constant 2005 US) in Syrian Arab Republic in 1992 to that in 1994?
Offer a very short reply. 0.7. What is the ratio of the Earning from trade(constant 2005 US) of Canada in 1992 to that in 1995?
Give a very brief answer. 0.73. What is the ratio of the Earning from trade(constant 2005 US) of Sierra Leone in 1992 to that in 1995?
Ensure brevity in your answer.  2.37. What is the ratio of the Earning from trade(constant 2005 US) of Syrian Arab Republic in 1992 to that in 1995?
Give a very brief answer. 0.69. What is the ratio of the Earning from trade(constant 2005 US) in Canada in 1992 to that in 1996?
Make the answer very short. 0.69. What is the ratio of the Earning from trade(constant 2005 US) of Sierra Leone in 1992 to that in 1996?
Keep it short and to the point. 1.34. What is the ratio of the Earning from trade(constant 2005 US) of Syrian Arab Republic in 1992 to that in 1996?
Your answer should be compact. 0.54. What is the ratio of the Earning from trade(constant 2005 US) in Canada in 1993 to that in 1994?
Ensure brevity in your answer.  0.89. What is the ratio of the Earning from trade(constant 2005 US) of Sierra Leone in 1993 to that in 1994?
Offer a terse response. 1.31. What is the ratio of the Earning from trade(constant 2005 US) in Syrian Arab Republic in 1993 to that in 1994?
Ensure brevity in your answer.  0.77. What is the ratio of the Earning from trade(constant 2005 US) of Canada in 1993 to that in 1995?
Ensure brevity in your answer.  0.81. What is the ratio of the Earning from trade(constant 2005 US) in Sierra Leone in 1993 to that in 1995?
Give a very brief answer. 2.05. What is the ratio of the Earning from trade(constant 2005 US) in Syrian Arab Republic in 1993 to that in 1995?
Your answer should be very brief. 0.76. What is the ratio of the Earning from trade(constant 2005 US) of Canada in 1993 to that in 1996?
Your answer should be compact. 0.77. What is the ratio of the Earning from trade(constant 2005 US) in Sierra Leone in 1993 to that in 1996?
Offer a terse response. 1.16. What is the ratio of the Earning from trade(constant 2005 US) of Syrian Arab Republic in 1993 to that in 1996?
Give a very brief answer. 0.6. What is the ratio of the Earning from trade(constant 2005 US) of Canada in 1994 to that in 1995?
Offer a terse response. 0.92. What is the ratio of the Earning from trade(constant 2005 US) in Sierra Leone in 1994 to that in 1995?
Ensure brevity in your answer.  1.57. What is the ratio of the Earning from trade(constant 2005 US) of Syrian Arab Republic in 1994 to that in 1995?
Give a very brief answer. 0.98. What is the ratio of the Earning from trade(constant 2005 US) in Canada in 1994 to that in 1996?
Your response must be concise. 0.87. What is the ratio of the Earning from trade(constant 2005 US) of Sierra Leone in 1994 to that in 1996?
Offer a very short reply. 0.89. What is the ratio of the Earning from trade(constant 2005 US) in Syrian Arab Republic in 1994 to that in 1996?
Your answer should be compact. 0.77. What is the ratio of the Earning from trade(constant 2005 US) in Canada in 1995 to that in 1996?
Your response must be concise. 0.95. What is the ratio of the Earning from trade(constant 2005 US) of Sierra Leone in 1995 to that in 1996?
Provide a succinct answer. 0.57. What is the ratio of the Earning from trade(constant 2005 US) in Syrian Arab Republic in 1995 to that in 1996?
Offer a very short reply. 0.79. What is the difference between the highest and the second highest Earning from trade(constant 2005 US) in Canada?
Your response must be concise. 1.56e+1. What is the difference between the highest and the second highest Earning from trade(constant 2005 US) in Sierra Leone?
Keep it short and to the point. 1.12e+07. What is the difference between the highest and the second highest Earning from trade(constant 2005 US) of Syrian Arab Republic?
Your answer should be compact. 1.68e+09. What is the difference between the highest and the lowest Earning from trade(constant 2005 US) of Canada?
Offer a very short reply. 1.12e+11. What is the difference between the highest and the lowest Earning from trade(constant 2005 US) of Sierra Leone?
Provide a short and direct response. 1.14e+08. What is the difference between the highest and the lowest Earning from trade(constant 2005 US) in Syrian Arab Republic?
Offer a very short reply. 4.77e+09. 